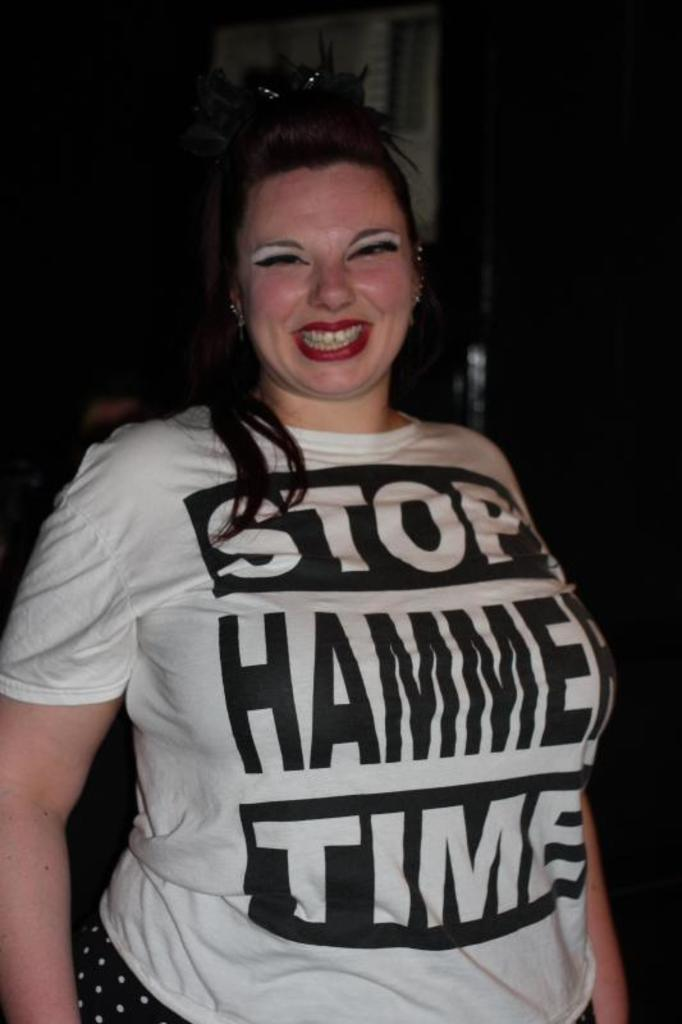Provide a one-sentence caption for the provided image. A woman wearing a white and black "Stop Hammer Time" t-shirt. 